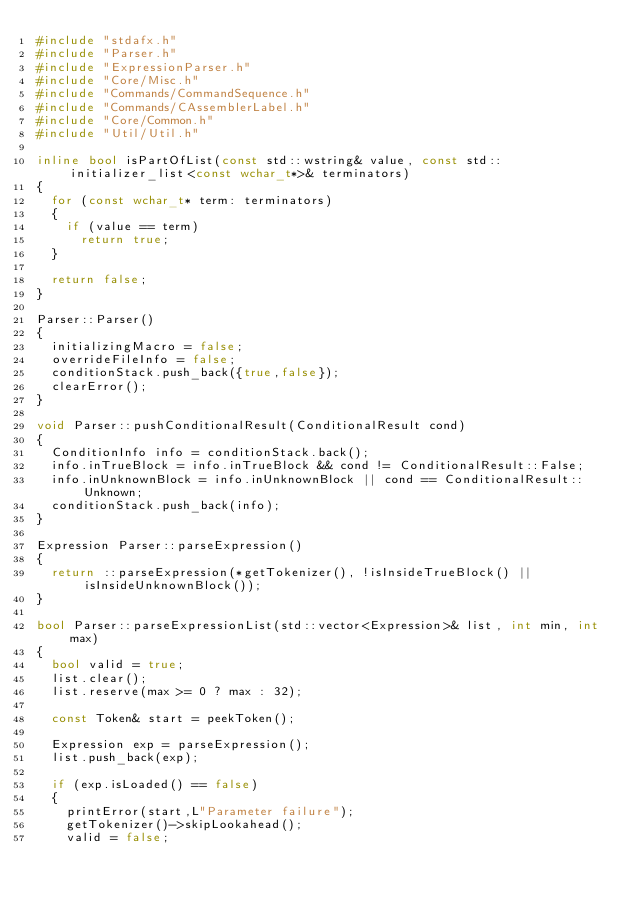Convert code to text. <code><loc_0><loc_0><loc_500><loc_500><_C++_>#include "stdafx.h"
#include "Parser.h"
#include "ExpressionParser.h"
#include "Core/Misc.h"
#include "Commands/CommandSequence.h"
#include "Commands/CAssemblerLabel.h"
#include "Core/Common.h"
#include "Util/Util.h"

inline bool isPartOfList(const std::wstring& value, const std::initializer_list<const wchar_t*>& terminators)
{
	for (const wchar_t* term: terminators)
	{
		if (value == term)
			return true;
	}

	return false;
}

Parser::Parser()
{
	initializingMacro = false;
	overrideFileInfo = false;
	conditionStack.push_back({true,false});
	clearError();
}

void Parser::pushConditionalResult(ConditionalResult cond)
{
	ConditionInfo info = conditionStack.back();
	info.inTrueBlock = info.inTrueBlock && cond != ConditionalResult::False;
	info.inUnknownBlock = info.inUnknownBlock || cond == ConditionalResult::Unknown;
	conditionStack.push_back(info);
}

Expression Parser::parseExpression()
{
	return ::parseExpression(*getTokenizer(), !isInsideTrueBlock() || isInsideUnknownBlock());
}

bool Parser::parseExpressionList(std::vector<Expression>& list, int min, int max)
{
	bool valid = true;
	list.clear();
	list.reserve(max >= 0 ? max : 32);

	const Token& start = peekToken();

	Expression exp = parseExpression();
	list.push_back(exp);

	if (exp.isLoaded() == false)
	{
		printError(start,L"Parameter failure");
		getTokenizer()->skipLookahead();
		valid = false;</code> 